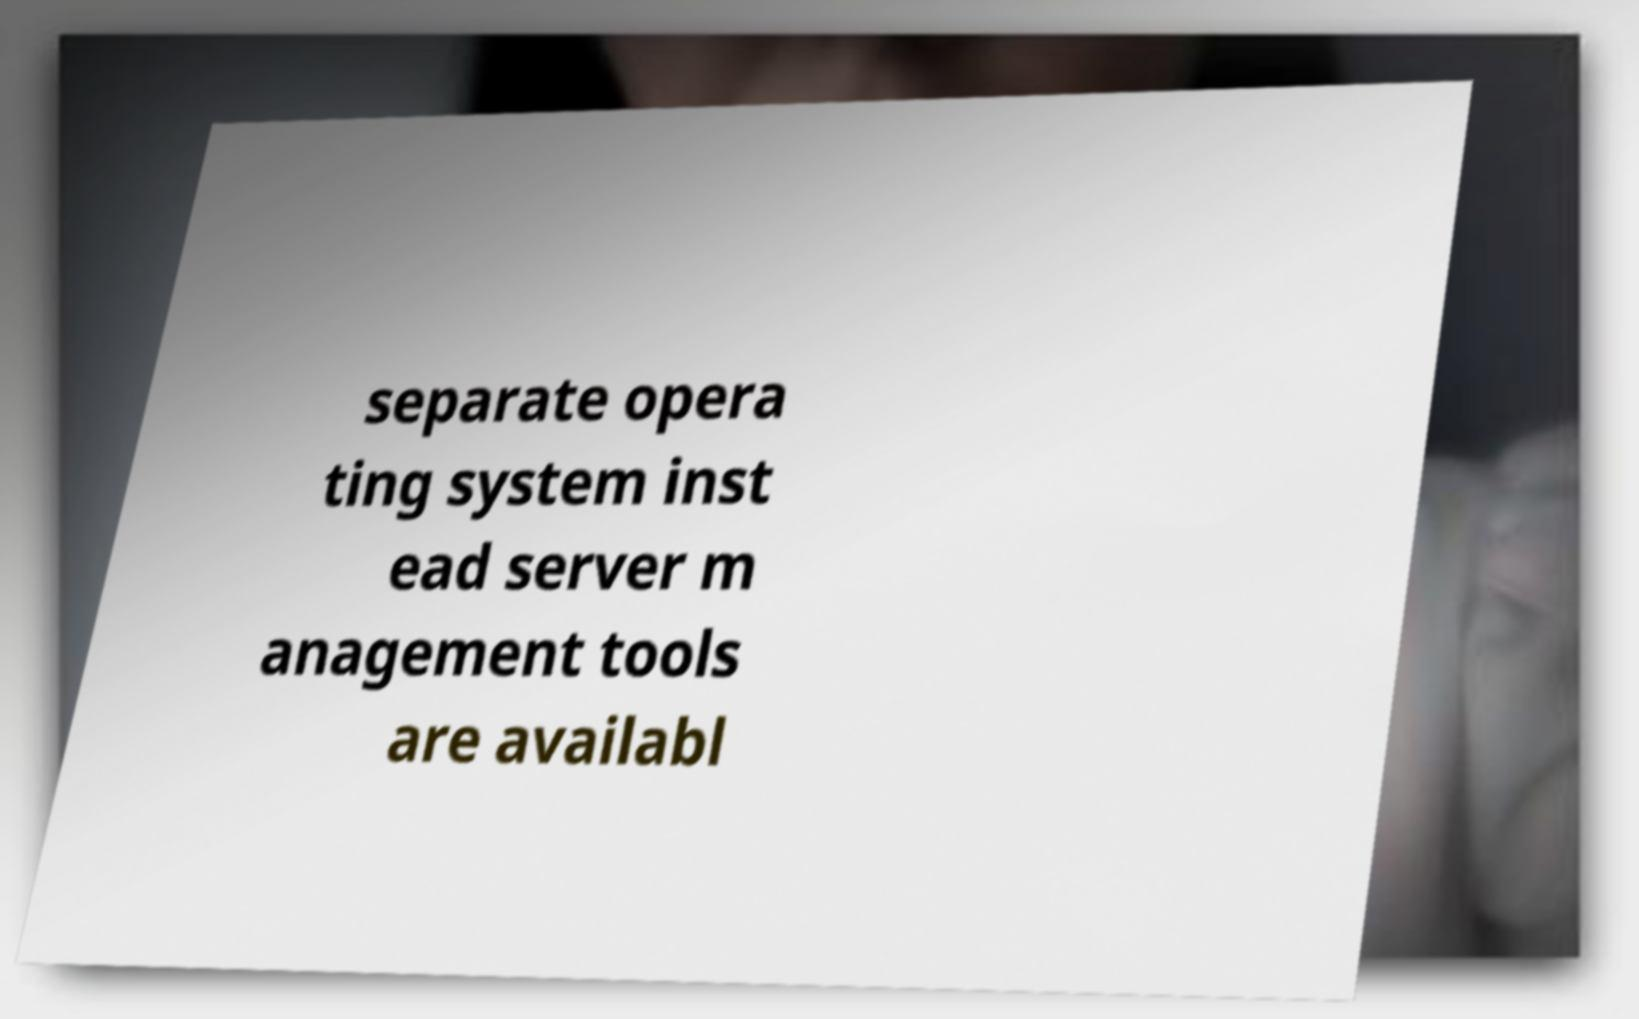Could you extract and type out the text from this image? separate opera ting system inst ead server m anagement tools are availabl 